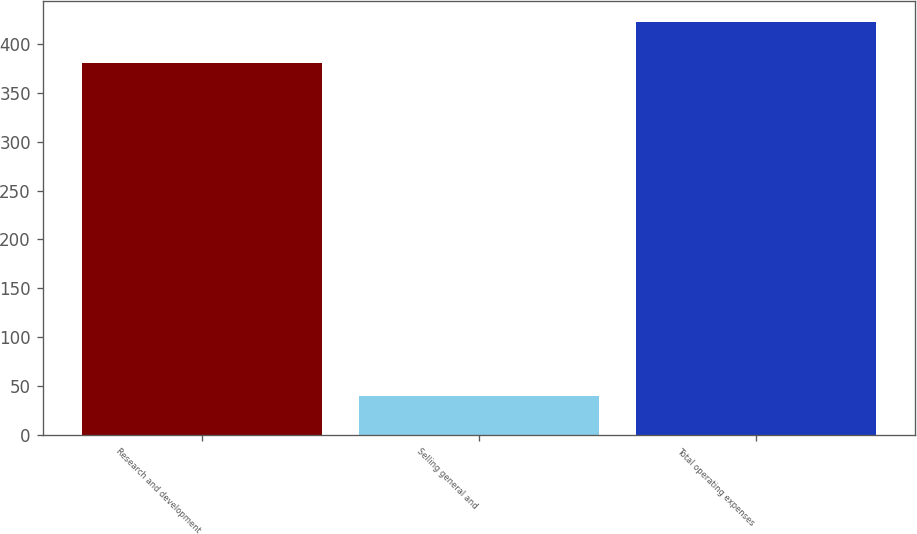Convert chart. <chart><loc_0><loc_0><loc_500><loc_500><bar_chart><fcel>Research and development<fcel>Selling general and<fcel>Total operating expenses<nl><fcel>380<fcel>40.4<fcel>422.1<nl></chart> 